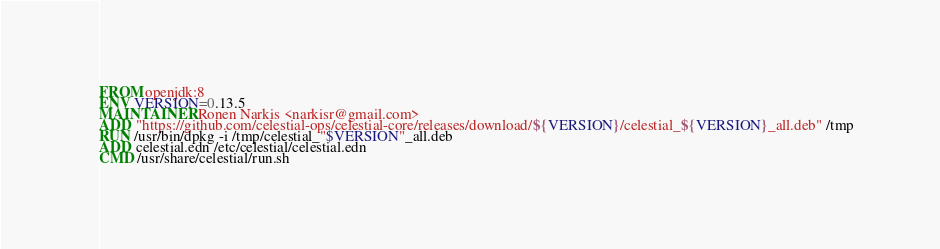<code> <loc_0><loc_0><loc_500><loc_500><_Dockerfile_>FROM openjdk:8
ENV VERSION=0.13.5
MAINTAINER Ronen Narkis <narkisr@gmail.com>
ADD "https://github.com/celestial-ops/celestial-core/releases/download/${VERSION}/celestial_${VERSION}_all.deb" /tmp
RUN /usr/bin/dpkg -i /tmp/celestial_"$VERSION"_all.deb
ADD celestial.edn /etc/celestial/celestial.edn
CMD /usr/share/celestial/run.sh
</code> 